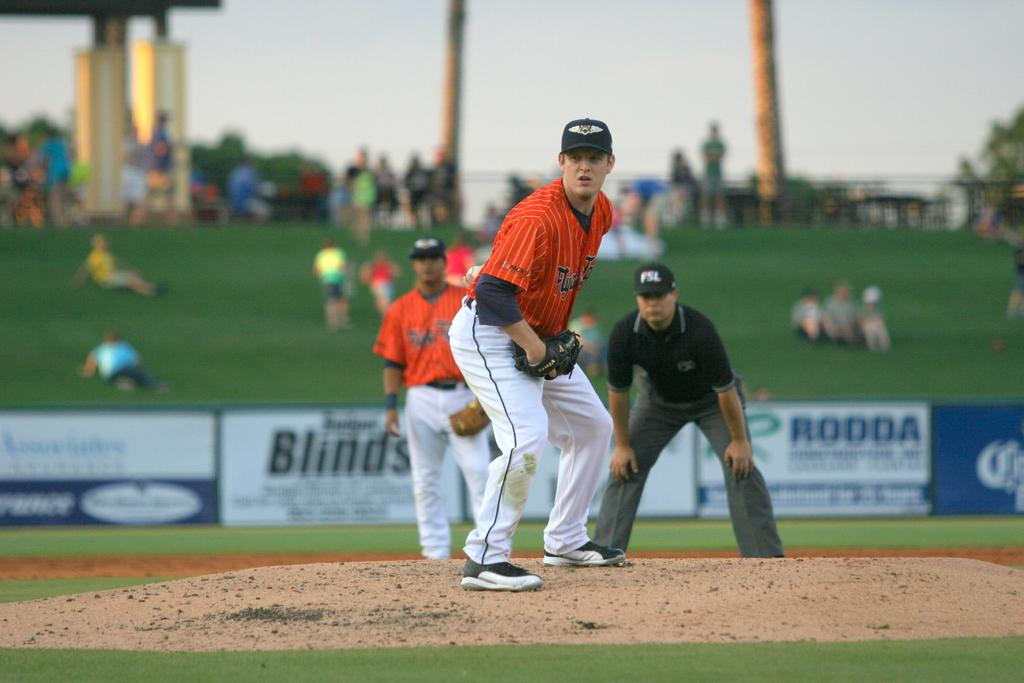Provide a one-sentence caption for the provided image. A baseball field displays a banner with RODDA on it. 